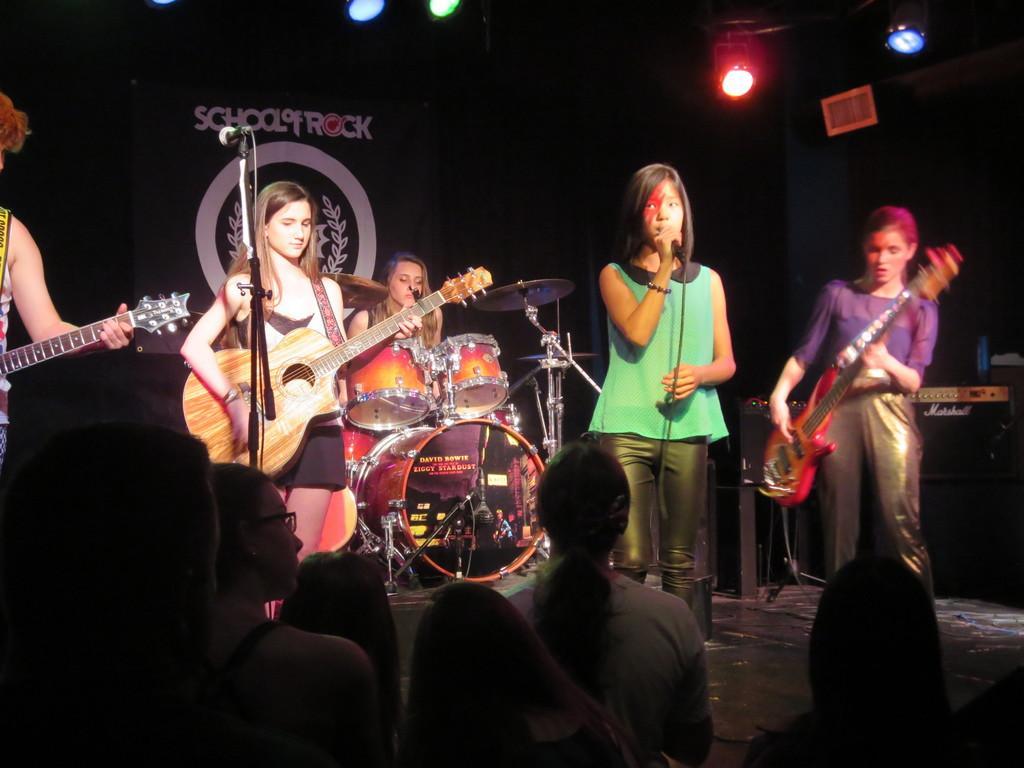Can you describe this image briefly? In this image there are group of people and some of them are standing and some of them are sitting on the stage there are some people who are standing on the right side there is one woman who is standing and she is holding a guitar. Beside her there is another woman who is standing and she is holding a mike and it seems that she is singing. On the left side there is another woman who is standing and she is holding a guitar in front of her there is one mike beside her in the middle there is another woman who is sitting and in front of her there are drums and on the left side there is another person and he is holding a guitar. On the top there is ceiling and lights are there. 